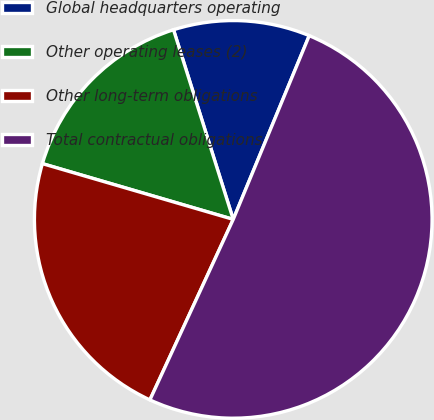Convert chart. <chart><loc_0><loc_0><loc_500><loc_500><pie_chart><fcel>Global headquarters operating<fcel>Other operating leases (2)<fcel>Other long-term obligations<fcel>Total contractual obligations<nl><fcel>11.1%<fcel>15.62%<fcel>22.64%<fcel>50.64%<nl></chart> 